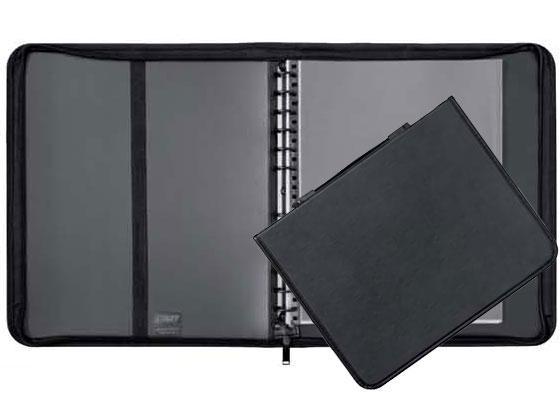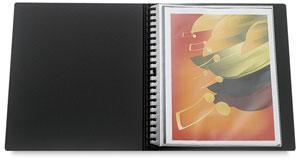The first image is the image on the left, the second image is the image on the right. Examine the images to the left and right. Is the description "An image shows one closed black binder with a colored label on the front." accurate? Answer yes or no. No. The first image is the image on the left, the second image is the image on the right. Examine the images to the left and right. Is the description "One photo features a single closed binder with a brand label on the front." accurate? Answer yes or no. No. 